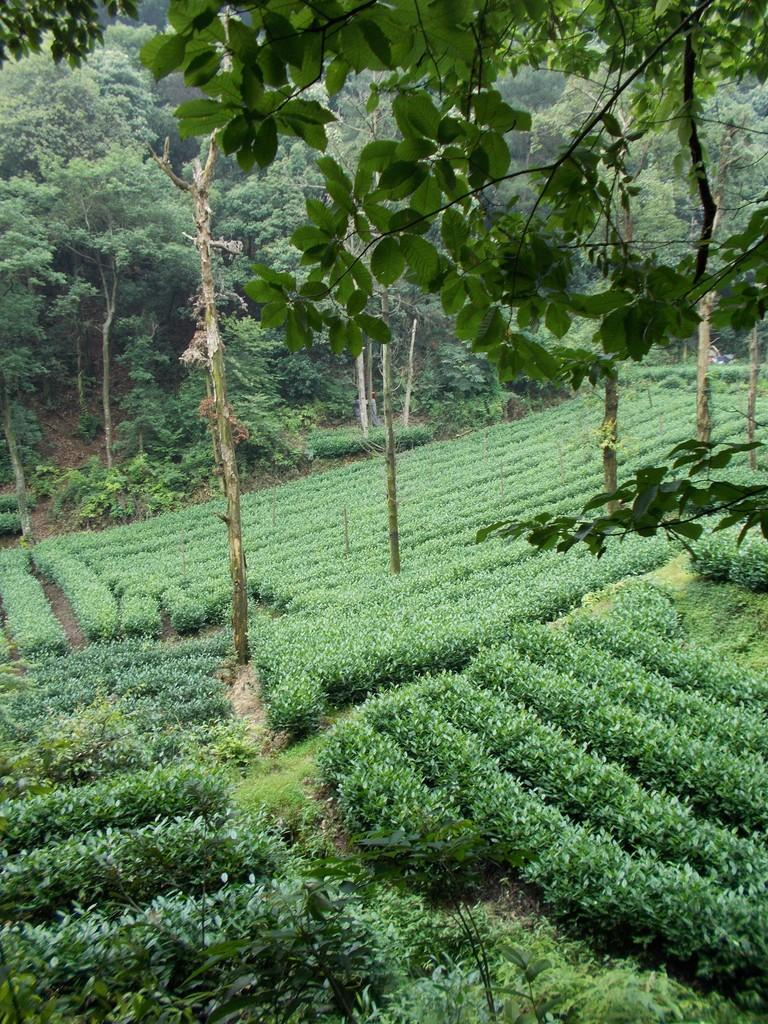What type of vegetation is present on the ground in the image? There are plants on the ground in the image. What can be seen in the background of the image? There are trees in the background of the image. What type of advertisement can be seen on the wishing well in the image? There is no advertisement or wishing well present in the image; it features plants on the ground and trees in the background. What type of quiver is visible on the person holding the bow in the image? There is no person holding a bow or quiver present in the image. 